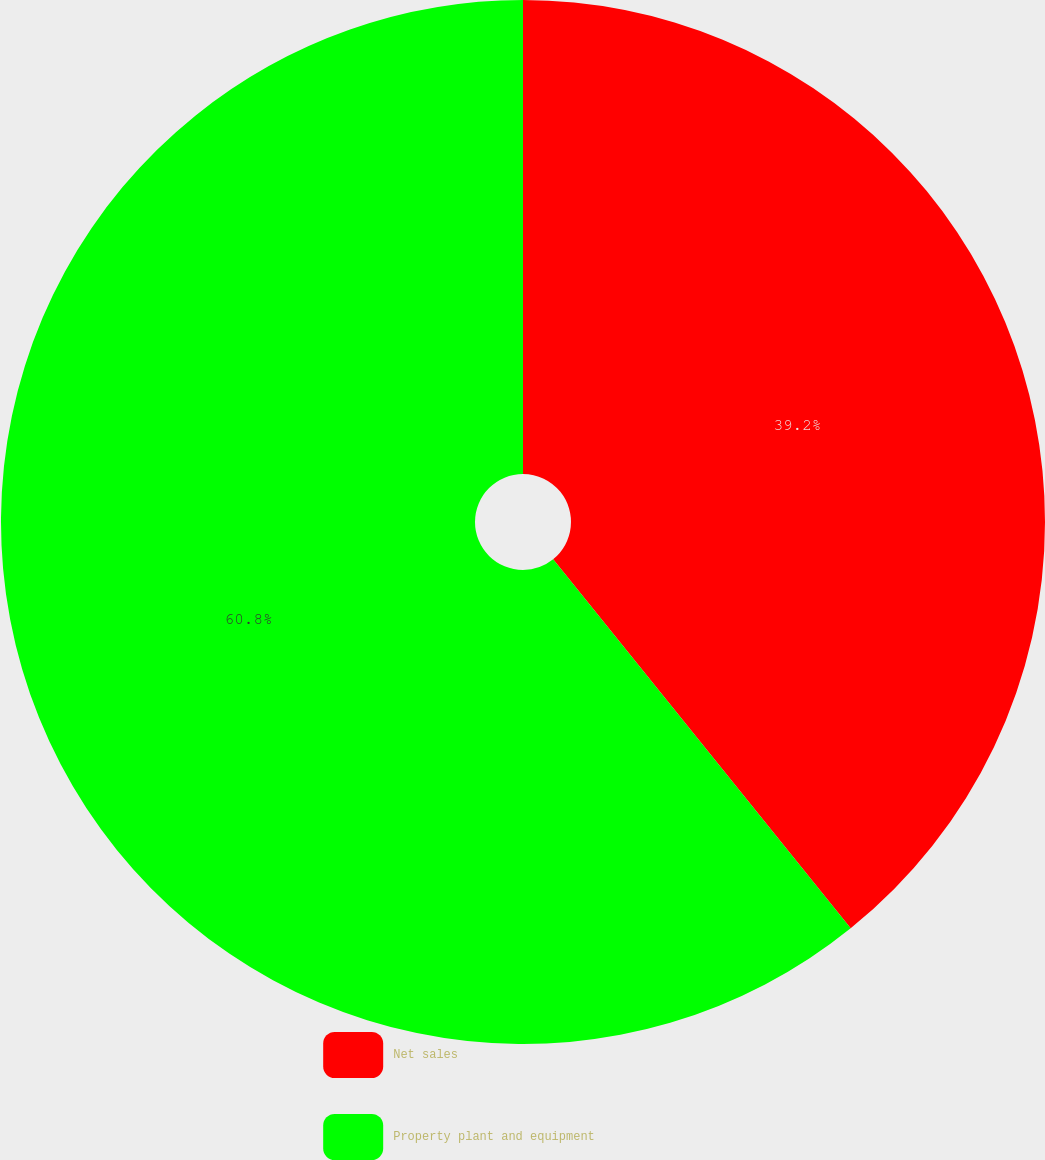Convert chart. <chart><loc_0><loc_0><loc_500><loc_500><pie_chart><fcel>Net sales<fcel>Property plant and equipment<nl><fcel>39.2%<fcel>60.8%<nl></chart> 